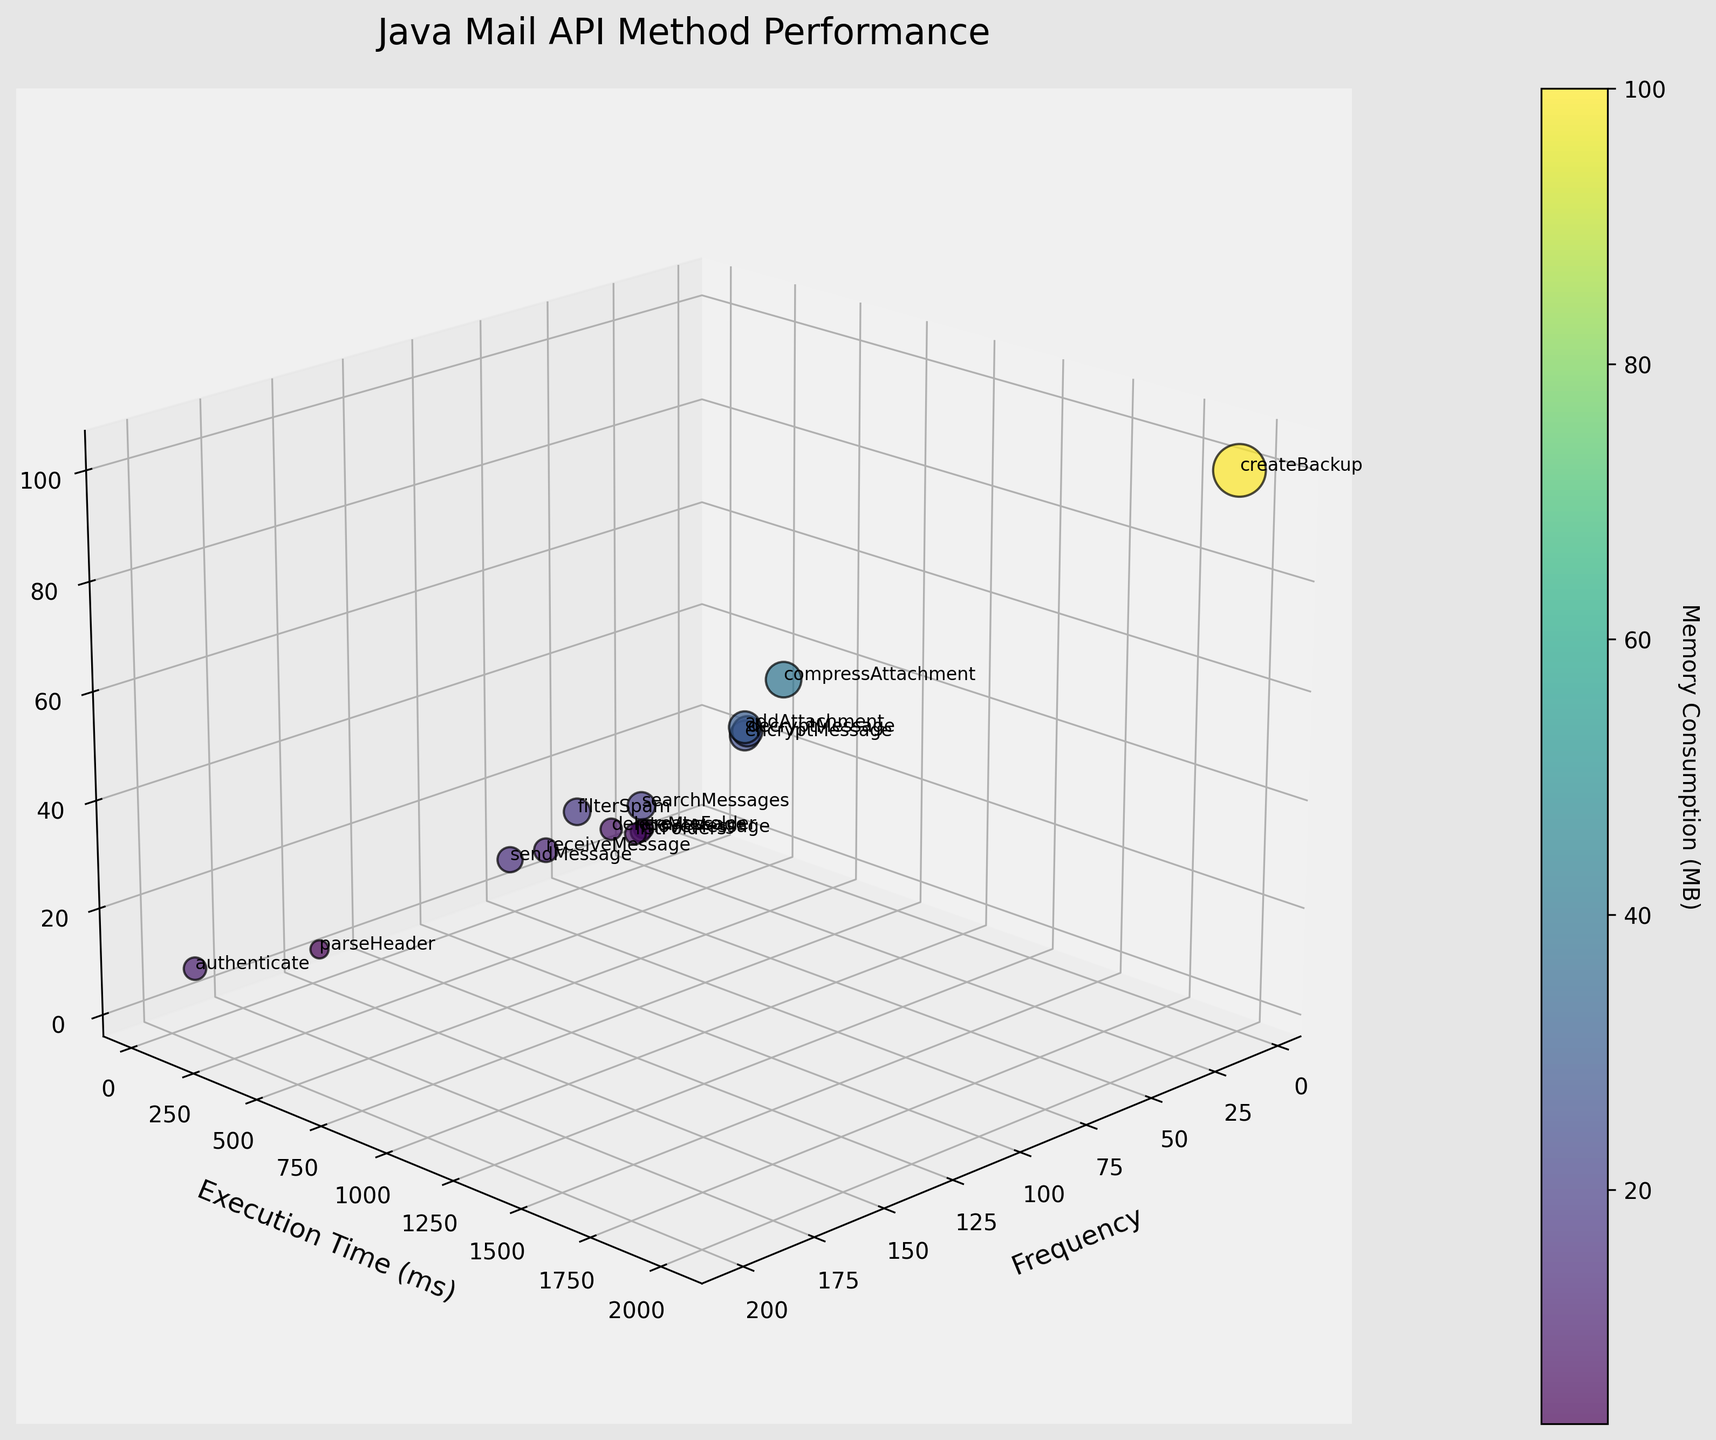What is the title of the plot? The title of the plot is displayed at the top center of the figure. It reads "Java Mail API Method Performance".
Answer: Java Mail API Method Performance How many methods are plotted in the figure? Each method is represented by a distinct point in the 3D plot, and the number of methods can be counted directly from these points.
Answer: 15 Which method has the highest frequency? By examining the 'Frequency' axis, you can identify the data point located at the highest value. The label next to this point shows the method name.
Answer: authenticate What is the execution time for the method with the highest memory consumption? Identify the data point with the highest position on the 'Memory Consumption (MB)' axis, then check its corresponding value on the 'Execution Time (ms)' axis.
Answer: 2000 ms Which method has the lowest memory consumption and what is its frequency? Locate the data point with the lowest value along the 'Memory Consumption (MB)' axis and observe its corresponding 'Frequency'. The label next to this point shows the method name.
Answer: parseHeader, 150 Which method consumes more memory: 'sendMessage' or 'receiveMessage'? Identify the positions for 'sendMessage' and 'receiveMessage' on the 'Memory Consumption (MB)' axis and compare their values.
Answer: sendMessage Which method takes the longest execution time and what is its frequency? Locate the data point positioned highest on the 'Execution Time (ms)' axis and observe its corresponding 'Frequency'. The method name is labeled next to the point.
Answer: createBackup, 5 What is the average memory consumption of 'sendMessage', 'receiveMessage', and 'listFolders'? Identify the memory values for the methods 'sendMessage' (15 MB), 'receiveMessage' (12 MB), and 'listFolders' (7 MB). Compute the average: (15 + 12 + 7) / 3 = 34 / 3 = 11.33.
Answer: 11.33 MB Which two methods have execution times closest to each other? Compare the 'Execution Time (ms)' values and identify the two methods whose values are the least different.
Answer: decryptMessage and encryptMessage Which method has the second highest execution time and what is its memory consumption? Identify the method with the highest execution time. Then, identify the method with the next highest value. Observe its corresponding 'Memory Consumption (MB)'.
Answer: compressAttachment, 40 MB 